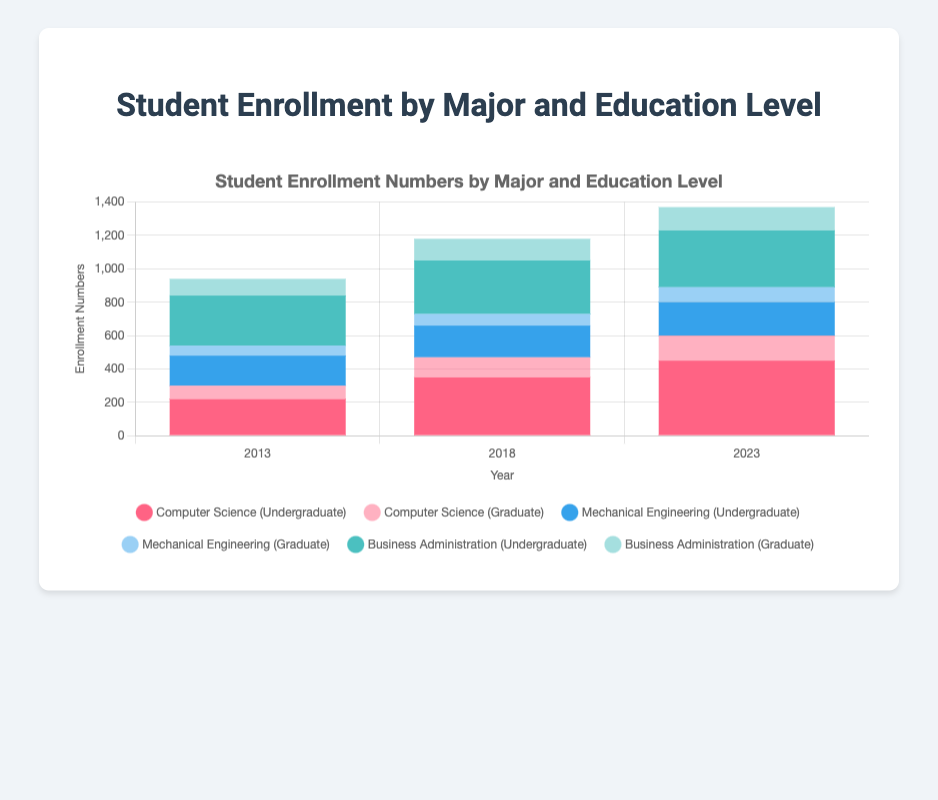What is the total enrollment for Computer Science in 2023? To find the total enrollment for Computer Science in 2023, sum the enrollment numbers for both Undergraduate and Graduate levels: 450 (Undergraduate) + 150 (Graduate) = 600
Answer: 600 Did Undergraduate enrollment in Mechanical Engineering increase from 2013 to 2023? Compare the enrollment numbers for Mechanical Engineering undergraduates in 2013 and 2023. In 2013, the number is 180, and in 2023, it is 200. Since 200 is greater than 180, there was an increase.
Answer: Yes Which major had the highest total enrollment in 2018? To find the major with the highest total enrollment in 2018, sum the enrollment numbers for both Undergraduate and Graduate levels for each major and compare. Computer Science: 350 (Undergraduate) + 120 (Graduate) = 470, Mechanical Engineering: 190 (Undergraduate) + 70 (Graduate) = 260, Business Administration: 320 (Undergraduate) + 130 (Graduate) = 450. The highest is Computer Science with 470.
Answer: Computer Science What was the change in Undergraduate enrollment for Business Administration from 2013 to 2018? To find the change, subtract the 2013 enrollment number from the 2018 enrollment number for Business Administration undergraduates: 320 (2018) - 300 (2013) = 20
Answer: 20 Which education level had more students enrolled in 2023 for Business Administration, Undergraduate or Graduate? Compare the enrollment numbers for Business Administration in 2023 at the Undergraduate and Graduate levels. Undergraduate enrollment is 340 and Graduate enrollment is 140. 340 is greater than 140, so Undergraduate had more students enrolled.
Answer: Undergraduate How did the total enrollment in Mechanical Engineering change from 2013 to 2023? Sum the total enrollment numbers for both Undergraduate and Graduate levels for each year and compare them. For 2013: 180 (Undergraduate) + 60 (Graduate) = 240. For 2023: 200 (Undergraduate) + 90 (Graduate) = 290. The increase is 290 - 240 = 50.
Answer: Increased by 50 Among all majors in 2018, which major and level had the smallest enrollment number? Check each major and level's enrollment numbers in 2018: Computer Science Graduate: 120, Computer Science Undergraduate: 350, Mechanical Engineering Graduate: 70, Mechanical Engineering Undergraduate: 190, Business Administration Graduate: 130, Business Administration Undergraduate: 320. The smallest enrollment is Mechanical Engineering Graduate with 70.
Answer: Mechanical Engineering Graduate By how much did the enrollment for Graduate Computer Science change from 2018 to 2023? To find the change, subtract the 2018 enrollment number from the 2023 enrollment number for Graduate Computer Science: 150 (2023) - 120 (2018) = 30
Answer: 30 Which year had the highest total enrollment across all majors and levels? Calculate the total enrollment for each year by summing up the enrollment numbers across all majors and levels. For 2013: 220 + 180 + 300 + 80 + 60 + 100 = 940. For 2018: 350 + 190 + 320 + 120 + 70 + 130 = 1180. For 2023: 450 + 200 + 340 + 150 + 90 + 140 = 1370. The highest total enrollment is in 2023 with 1370.
Answer: 2023 